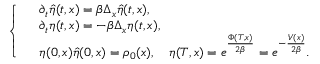<formula> <loc_0><loc_0><loc_500><loc_500>\left \{ \begin{array} { r l } & { \partial _ { t } \hat { \eta } ( t , x ) = \beta \Delta _ { x } \hat { \eta } ( t , x ) , } \\ & { \partial _ { t } \eta ( t , x ) = - \beta \Delta _ { x } \eta ( t , x ) , } \\ & { \eta ( 0 , x ) \hat { \eta } ( 0 , x ) = \rho _ { 0 } ( x ) , \quad \eta ( T , x ) = e ^ { \frac { \Phi ( T , x ) } { 2 \beta } } = e ^ { - \frac { V ( x ) } { 2 \beta } } . } \end{array}</formula> 